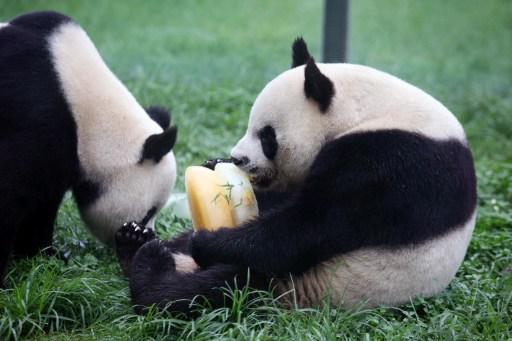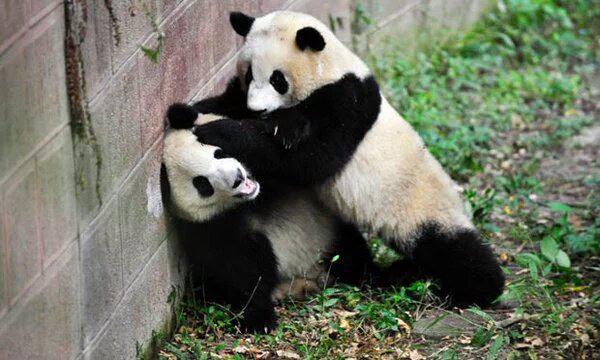The first image is the image on the left, the second image is the image on the right. Evaluate the accuracy of this statement regarding the images: "Two pandas are actively play-fighting in one image, and the other image contains two pandas who are not in direct contact.". Is it true? Answer yes or no. Yes. The first image is the image on the left, the second image is the image on the right. Examine the images to the left and right. Is the description "a mother panda is with her infant on the grass" accurate? Answer yes or no. No. 